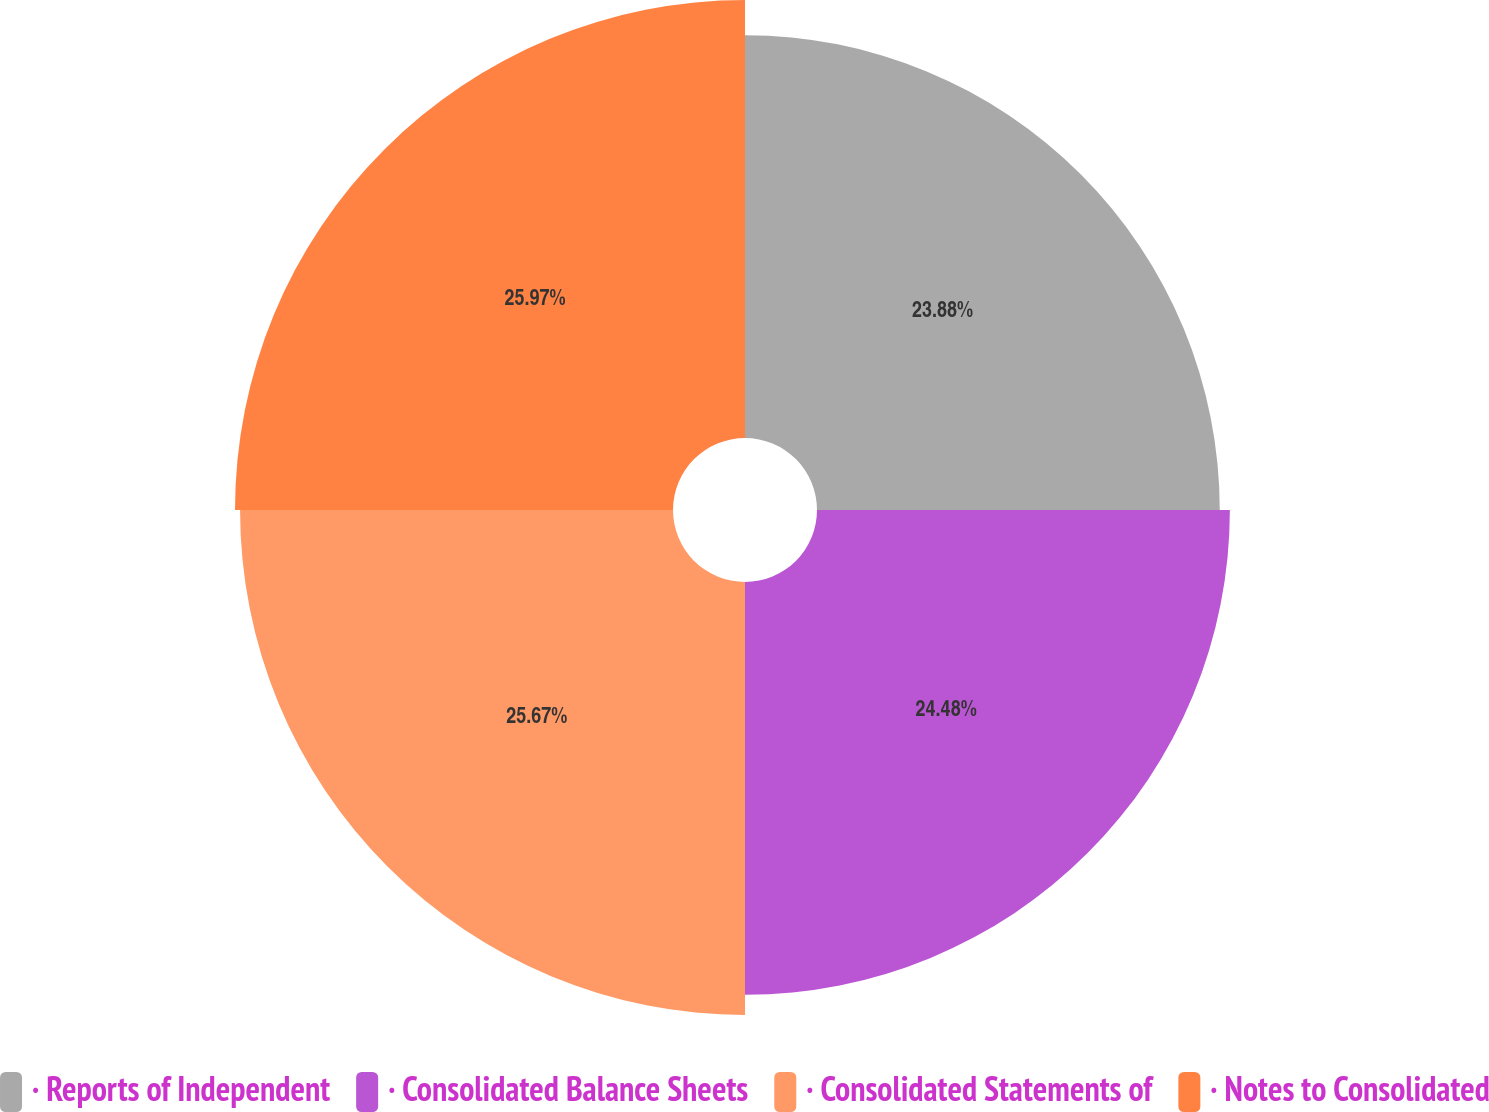Convert chart to OTSL. <chart><loc_0><loc_0><loc_500><loc_500><pie_chart><fcel>· Reports of Independent<fcel>· Consolidated Balance Sheets<fcel>· Consolidated Statements of<fcel>· Notes to Consolidated<nl><fcel>23.88%<fcel>24.48%<fcel>25.67%<fcel>25.97%<nl></chart> 